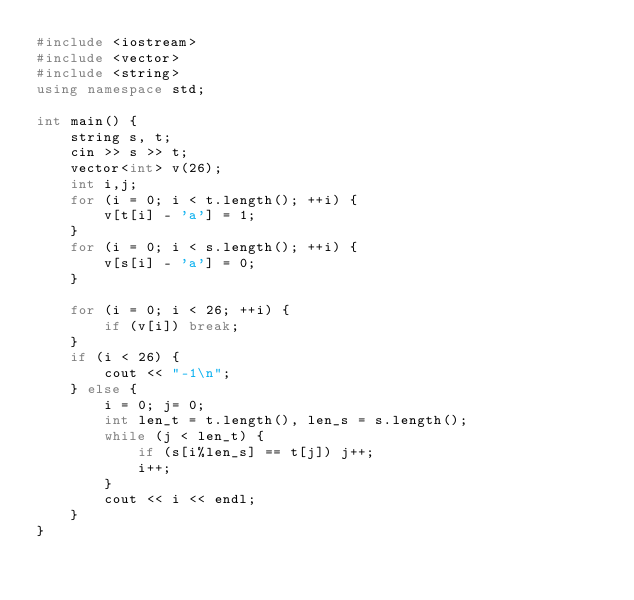Convert code to text. <code><loc_0><loc_0><loc_500><loc_500><_C++_>#include <iostream>
#include <vector>
#include <string>
using namespace std;

int main() {
    string s, t;
    cin >> s >> t;
    vector<int> v(26);
    int i,j;
    for (i = 0; i < t.length(); ++i) {
        v[t[i] - 'a'] = 1;
    }
    for (i = 0; i < s.length(); ++i) {
        v[s[i] - 'a'] = 0;
    }

    for (i = 0; i < 26; ++i) {
        if (v[i]) break;
    }
    if (i < 26) {
        cout << "-1\n";
    } else {
        i = 0; j= 0;
        int len_t = t.length(), len_s = s.length();
        while (j < len_t) {
            if (s[i%len_s] == t[j]) j++;
            i++;
        }
        cout << i << endl;
    }
}</code> 